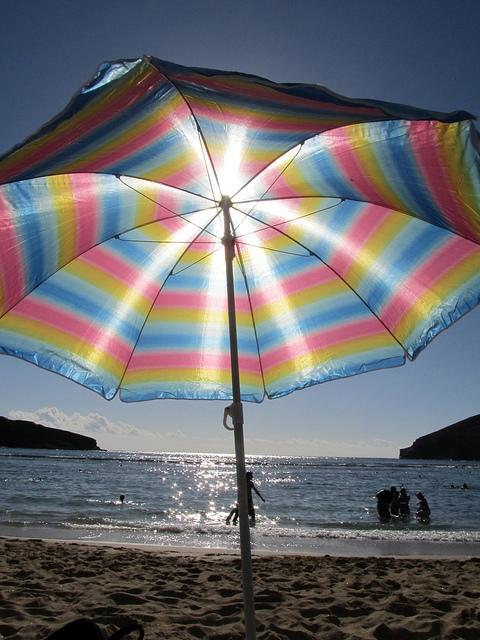What is planted in the sand? Please explain your reasoning. umbrella. The umbrella is there to let people sit in the shade. 